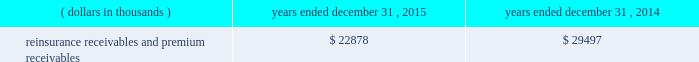Certain reclassifications and format changes have been made to prior years 2019 amounts to conform to the 2015 presentation .
Investments .
Fixed maturity and equity security investments available for sale , at market value , reflect unrealized appreciation and depreciation , as a result of temporary changes in market value during the period , in shareholders 2019 equity , net of income taxes in 201caccumulated other comprehensive income ( loss ) 201d in the consolidated balance sheets .
Fixed maturity and equity securities carried at fair value reflect fair value re- measurements as net realized capital gains and losses in the consolidated statements of operations and comprehensive income ( loss ) .
The company records changes in fair value for its fixed maturities available for sale , at market value through shareholders 2019 equity , net of taxes in accumulated other comprehensive income ( loss ) since cash flows from these investments will be primarily used to settle its reserve for losses and loss adjustment expense liabilities .
The company anticipates holding these investments for an extended period as the cash flow from interest and maturities will fund the projected payout of these liabilities .
Fixed maturities carried at fair value represent a portfolio of convertible bond securities , which have characteristics similar to equity securities and at times , designated foreign denominated fixed maturity securities , which will be used to settle loss and loss adjustment reserves in the same currency .
The company carries all of its equity securities at fair value except for mutual fund investments whose underlying investments are comprised of fixed maturity securities .
For equity securities , available for sale , at fair value , the company reflects changes in value as net realized capital gains and losses since these securities may be sold in the near term depending on financial market conditions .
Interest income on all fixed maturities and dividend income on all equity securities are included as part of net investment income in the consolidated statements of operations and comprehensive income ( loss ) .
Unrealized losses on fixed maturities , which are deemed other-than-temporary and related to the credit quality of a security , are charged to net income ( loss ) as net realized capital losses .
Short-term investments are stated at cost , which approximates market value .
Realized gains or losses on sales of investments are determined on the basis of identified cost .
For non- publicly traded securities , market prices are determined through the use of pricing models that evaluate securities relative to the u.s .
Treasury yield curve , taking into account the issue type , credit quality , and cash flow characteristics of each security .
For publicly traded securities , market value is based on quoted market prices or valuation models that use observable market inputs .
When a sector of the financial markets is inactive or illiquid , the company may use its own assumptions about future cash flows and risk-adjusted discount rates to determine fair value .
Retrospective adjustments are employed to recalculate the values of asset-backed securities .
Each acquisition lot is reviewed to recalculate the effective yield .
The recalculated effective yield is used to derive a book value as if the new yield were applied at the time of acquisition .
Outstanding principal factors from the time of acquisition to the adjustment date are used to calculate the prepayment history for all applicable securities .
Conditional prepayment rates , computed with life to date factor histories and weighted average maturities , are used to effect the calculation of projected and prepayments for pass-through security types .
Other invested assets include limited partnerships and rabbi trusts .
Limited partnerships are accounted for under the equity method of accounting , which can be recorded on a monthly or quarterly lag .
Uncollectible receivable balances .
The company provides reserves for uncollectible reinsurance recoverable and premium receivable balances based on management 2019s assessment of the collectability of the outstanding balances .
Such reserves are presented in the table below for the periods indicated. .

What is the percentage change in the balance of reinsurance receivables and premium receivables from 2014 to 2015? 
Computations: ((22878 - 29497) / 29497)
Answer: -0.2244. 